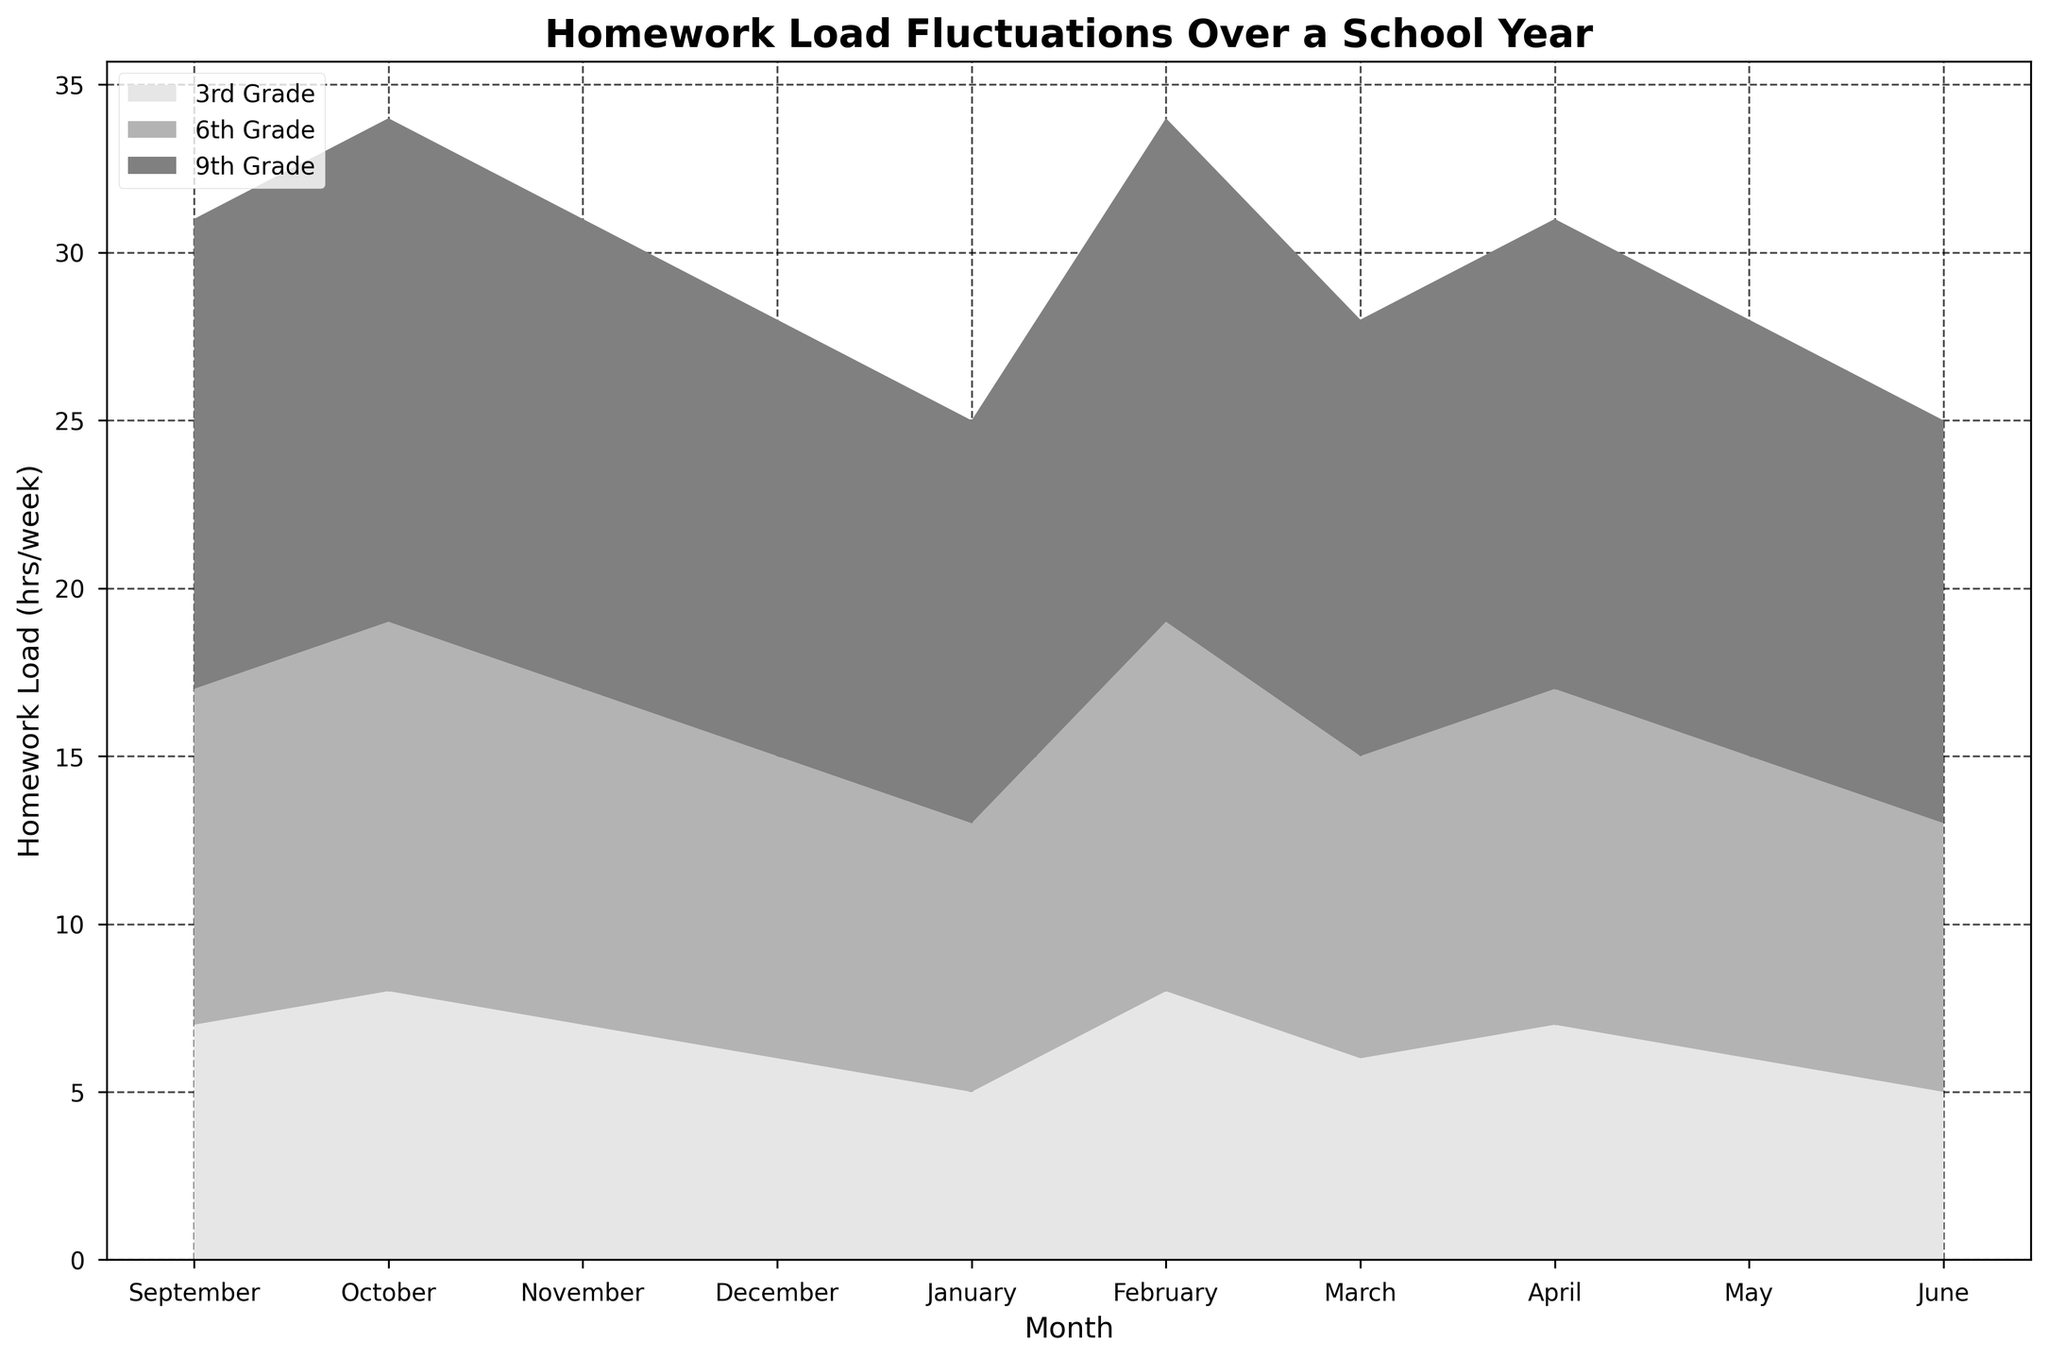What's the title of the chart? The title of the chart is displayed at the top. It reads "Homework Load Fluctuations Over a School Year."
Answer: Homework Load Fluctuations Over a School Year How does the homework load change for 3rd Grade from September to December? From the visual representation, locate the 3rd Grade segment for the months from September to December. The load increases from 5 to 8 hours per week.
Answer: It increases from 5 to 8 hours per week Which grade level has the highest homework load in December? Find December on the x-axis, then look for the segment with the highest value on the y-axis. The 9th Grade segment is the highest at 15 hours per week.
Answer: 9th Grade What is the homework load difference between March and June for 9th Grade? Locate March and June for 9th Grade. The load in March is 15 hours per week, and in June, it is 12 hours per week. The difference is 15 - 12.
Answer: 3 hours per week Does the 6th Grade homework load ever equal 11 hours per week? Find the 6th Grade segments and check for the value of 11 hours per week. It appears in December and March.
Answer: Yes Between which months does the 9th Grade see a decrease in homework load? Identify the 9th Grade segment and observe any decreases. Notable decreases are January to February, and April to May.
Answer: January to February, April to May What is the average homework load for the 3rd Grade over the entire school year? Sum all the monthly homework loads for 3rd Grade and divide by the number of months (10). (5+6+7+8+6+7+8+7+6+5)/10 = 65/10
Answer: 6.5 hours per week Are there any months where all three grade levels have the same academic performance? Check the GPA values indicated for all three grade levels across the months. All grades have a GPA of 3.3 in October and May.
Answer: October, May 